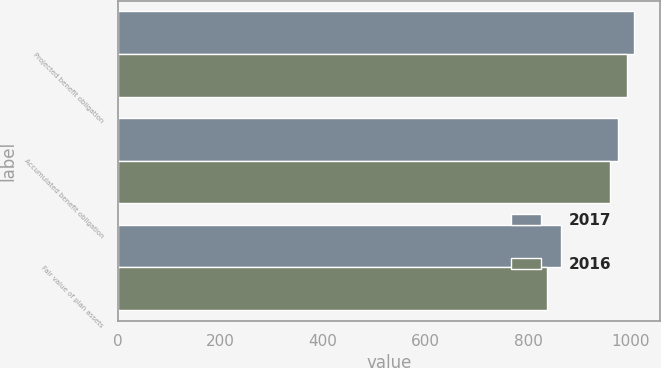<chart> <loc_0><loc_0><loc_500><loc_500><stacked_bar_chart><ecel><fcel>Projected benefit obligation<fcel>Accumulated benefit obligation<fcel>Fair value of plan assets<nl><fcel>2017<fcel>1007<fcel>976<fcel>864<nl><fcel>2016<fcel>993<fcel>960<fcel>837<nl></chart> 